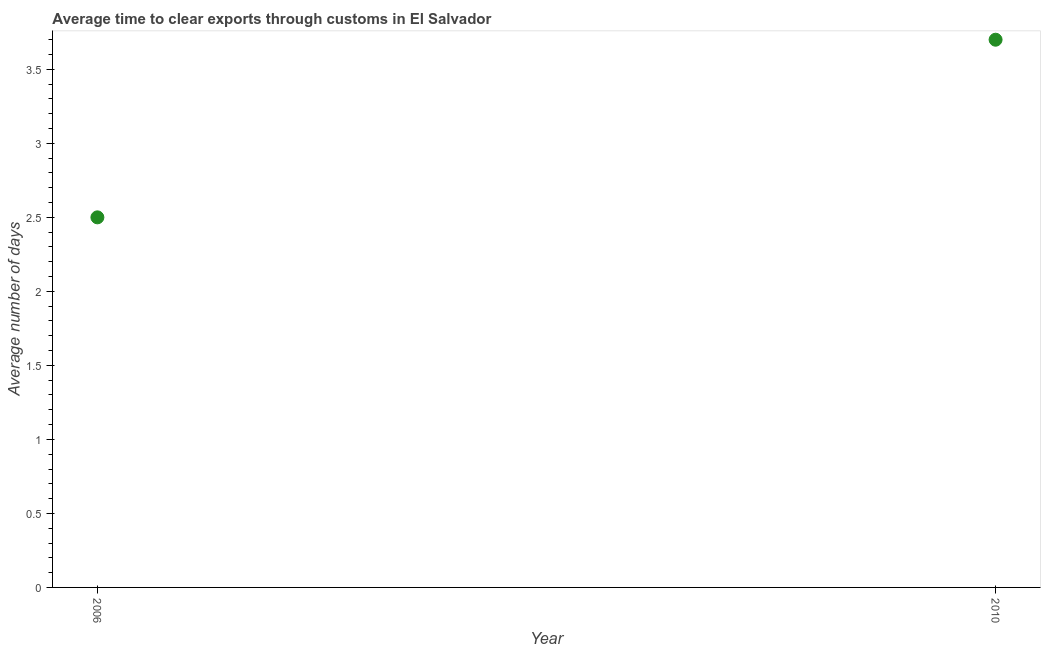Across all years, what is the minimum time to clear exports through customs?
Provide a succinct answer. 2.5. In which year was the time to clear exports through customs minimum?
Your response must be concise. 2006. What is the sum of the time to clear exports through customs?
Make the answer very short. 6.2. What is the difference between the time to clear exports through customs in 2006 and 2010?
Your answer should be very brief. -1.2. What is the median time to clear exports through customs?
Make the answer very short. 3.1. What is the ratio of the time to clear exports through customs in 2006 to that in 2010?
Provide a succinct answer. 0.68. Is the time to clear exports through customs in 2006 less than that in 2010?
Your answer should be compact. Yes. In how many years, is the time to clear exports through customs greater than the average time to clear exports through customs taken over all years?
Provide a succinct answer. 1. Does the time to clear exports through customs monotonically increase over the years?
Make the answer very short. Yes. What is the difference between two consecutive major ticks on the Y-axis?
Your response must be concise. 0.5. Are the values on the major ticks of Y-axis written in scientific E-notation?
Offer a very short reply. No. Does the graph contain any zero values?
Your answer should be very brief. No. What is the title of the graph?
Offer a terse response. Average time to clear exports through customs in El Salvador. What is the label or title of the X-axis?
Give a very brief answer. Year. What is the label or title of the Y-axis?
Ensure brevity in your answer.  Average number of days. What is the ratio of the Average number of days in 2006 to that in 2010?
Offer a very short reply. 0.68. 